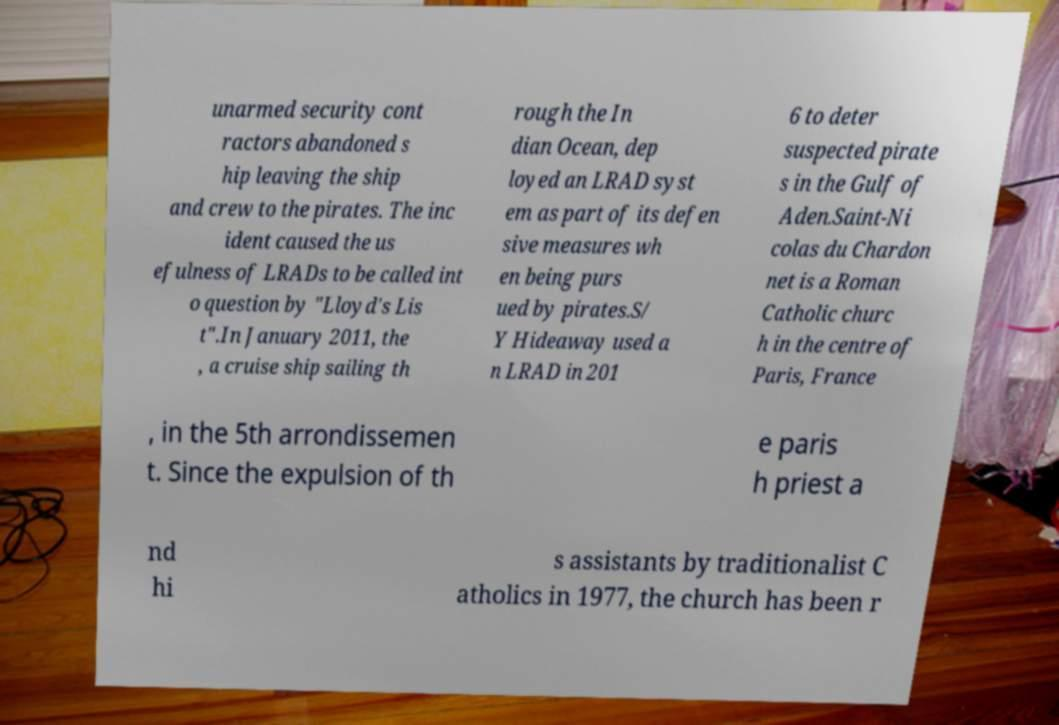Please read and relay the text visible in this image. What does it say? unarmed security cont ractors abandoned s hip leaving the ship and crew to the pirates. The inc ident caused the us efulness of LRADs to be called int o question by "Lloyd's Lis t".In January 2011, the , a cruise ship sailing th rough the In dian Ocean, dep loyed an LRAD syst em as part of its defen sive measures wh en being purs ued by pirates.S/ Y Hideaway used a n LRAD in 201 6 to deter suspected pirate s in the Gulf of Aden.Saint-Ni colas du Chardon net is a Roman Catholic churc h in the centre of Paris, France , in the 5th arrondissemen t. Since the expulsion of th e paris h priest a nd hi s assistants by traditionalist C atholics in 1977, the church has been r 